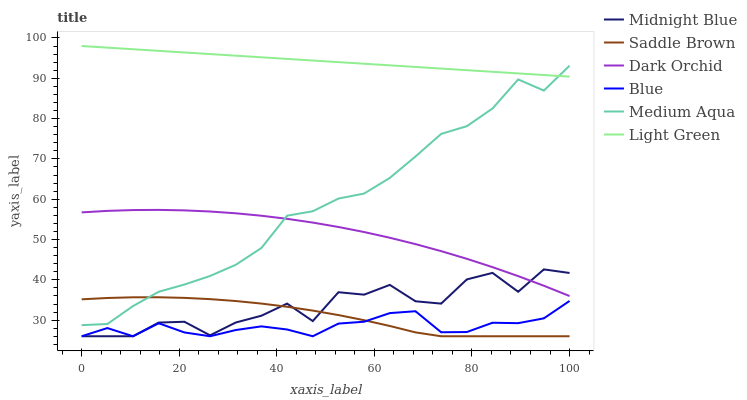Does Midnight Blue have the minimum area under the curve?
Answer yes or no. No. Does Midnight Blue have the maximum area under the curve?
Answer yes or no. No. Is Dark Orchid the smoothest?
Answer yes or no. No. Is Dark Orchid the roughest?
Answer yes or no. No. Does Dark Orchid have the lowest value?
Answer yes or no. No. Does Midnight Blue have the highest value?
Answer yes or no. No. Is Dark Orchid less than Light Green?
Answer yes or no. Yes. Is Light Green greater than Midnight Blue?
Answer yes or no. Yes. Does Dark Orchid intersect Light Green?
Answer yes or no. No. 